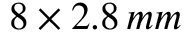Convert formula to latex. <formula><loc_0><loc_0><loc_500><loc_500>8 \times 2 . 8 \, m m</formula> 